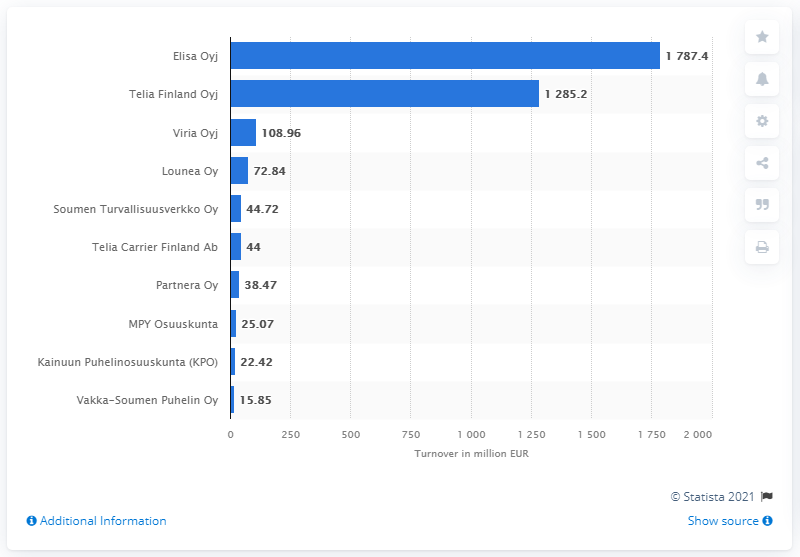Point out several critical features in this image. The value of the longest bar is 1787.4... Out of the values provided, two values exhibit a significant increase. In June 2021, Elisa Oyj's turnover was 1787.4.. In June 2021, Elisa Oyj was the telecommunication company in Finland with the highest turnover. The turnover of Telia Finland Oyj for the given period was 1,285.2 million. 